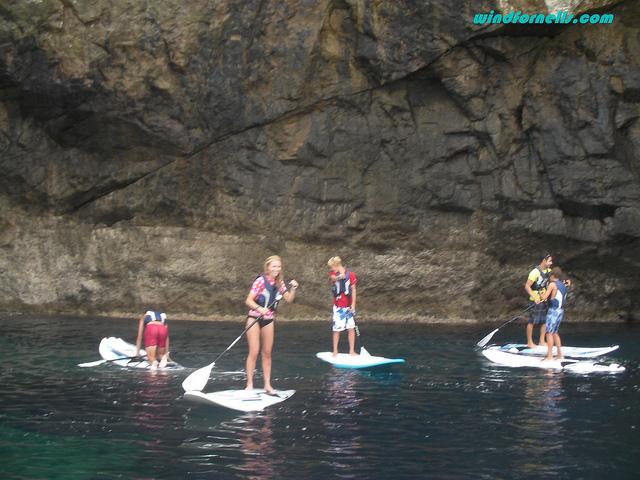Is everyone wearing life jackets?
Answer briefly. Yes. Is everyone holding a paddle?
Concise answer only. Yes. What is the website being advertised?
Concise answer only. Windfornellscom. Are these people walking on the water?
Quick response, please. No. 